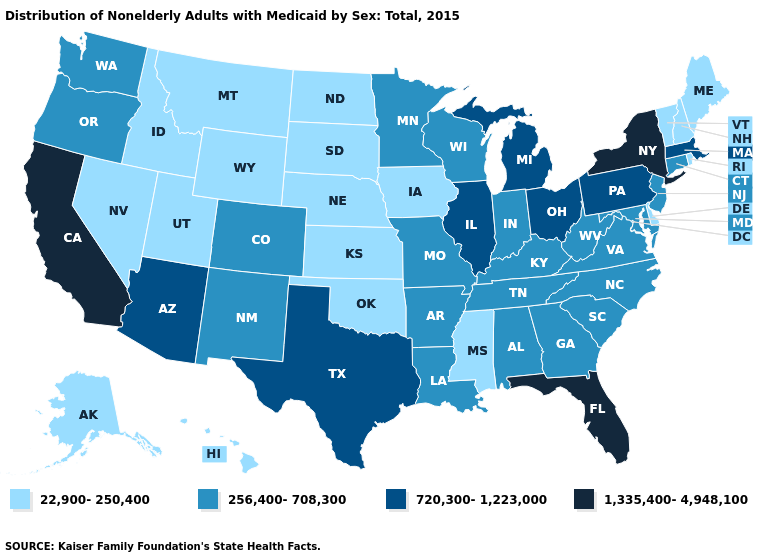Name the states that have a value in the range 1,335,400-4,948,100?
Be succinct. California, Florida, New York. What is the lowest value in the Northeast?
Keep it brief. 22,900-250,400. Does the first symbol in the legend represent the smallest category?
Short answer required. Yes. Which states have the highest value in the USA?
Write a very short answer. California, Florida, New York. Name the states that have a value in the range 720,300-1,223,000?
Write a very short answer. Arizona, Illinois, Massachusetts, Michigan, Ohio, Pennsylvania, Texas. What is the value of Utah?
Answer briefly. 22,900-250,400. Which states have the lowest value in the USA?
Keep it brief. Alaska, Delaware, Hawaii, Idaho, Iowa, Kansas, Maine, Mississippi, Montana, Nebraska, Nevada, New Hampshire, North Dakota, Oklahoma, Rhode Island, South Dakota, Utah, Vermont, Wyoming. Does North Dakota have a higher value than Arkansas?
Keep it brief. No. Among the states that border New York , which have the highest value?
Keep it brief. Massachusetts, Pennsylvania. What is the lowest value in states that border New Mexico?
Answer briefly. 22,900-250,400. Does the map have missing data?
Give a very brief answer. No. What is the value of Idaho?
Give a very brief answer. 22,900-250,400. How many symbols are there in the legend?
Answer briefly. 4. Does the map have missing data?
Write a very short answer. No. Name the states that have a value in the range 256,400-708,300?
Write a very short answer. Alabama, Arkansas, Colorado, Connecticut, Georgia, Indiana, Kentucky, Louisiana, Maryland, Minnesota, Missouri, New Jersey, New Mexico, North Carolina, Oregon, South Carolina, Tennessee, Virginia, Washington, West Virginia, Wisconsin. 